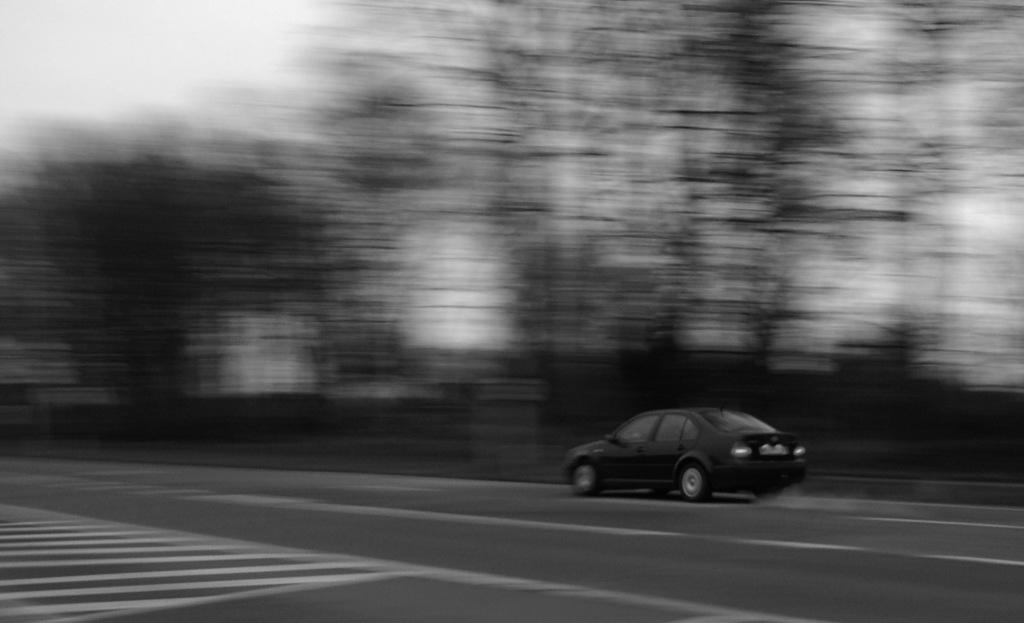What is the main subject of the image? There is a vehicle on the road in the image. What can be seen in the background of the image? There are many trees and the sky visible in the background of the image. How is the background of the image depicted? The background is blurred. What is the color scheme of the image? The image is in black and white color. What type of coil is being adjusted in the image? There is no coil present in the image. What kind of care is being provided to the vehicle in the image? The image does not show any care being provided to the vehicle; it only shows the vehicle on the road. 